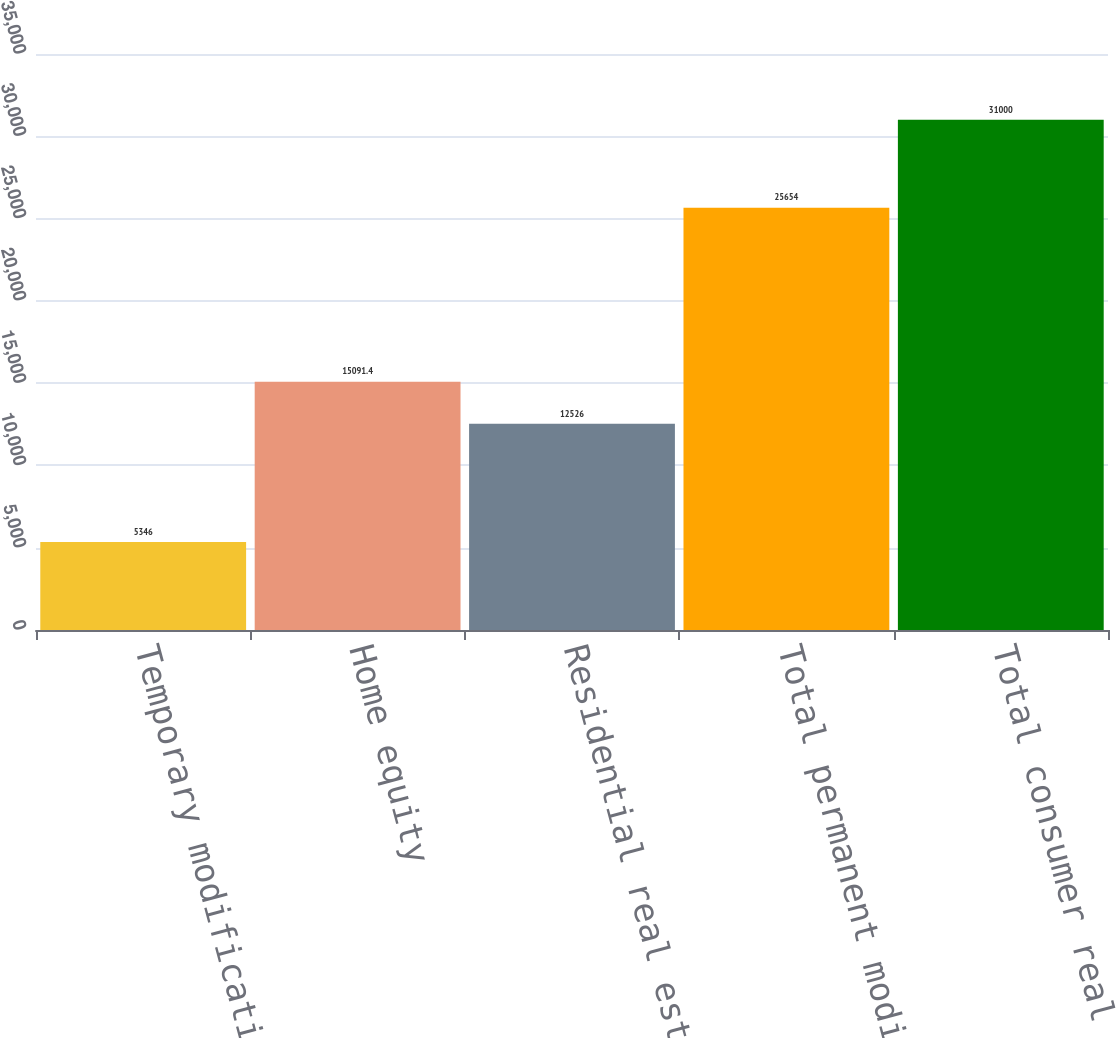Convert chart. <chart><loc_0><loc_0><loc_500><loc_500><bar_chart><fcel>Temporary modifications (a)<fcel>Home equity<fcel>Residential real estate<fcel>Total permanent modifications<fcel>Total consumer real estate<nl><fcel>5346<fcel>15091.4<fcel>12526<fcel>25654<fcel>31000<nl></chart> 